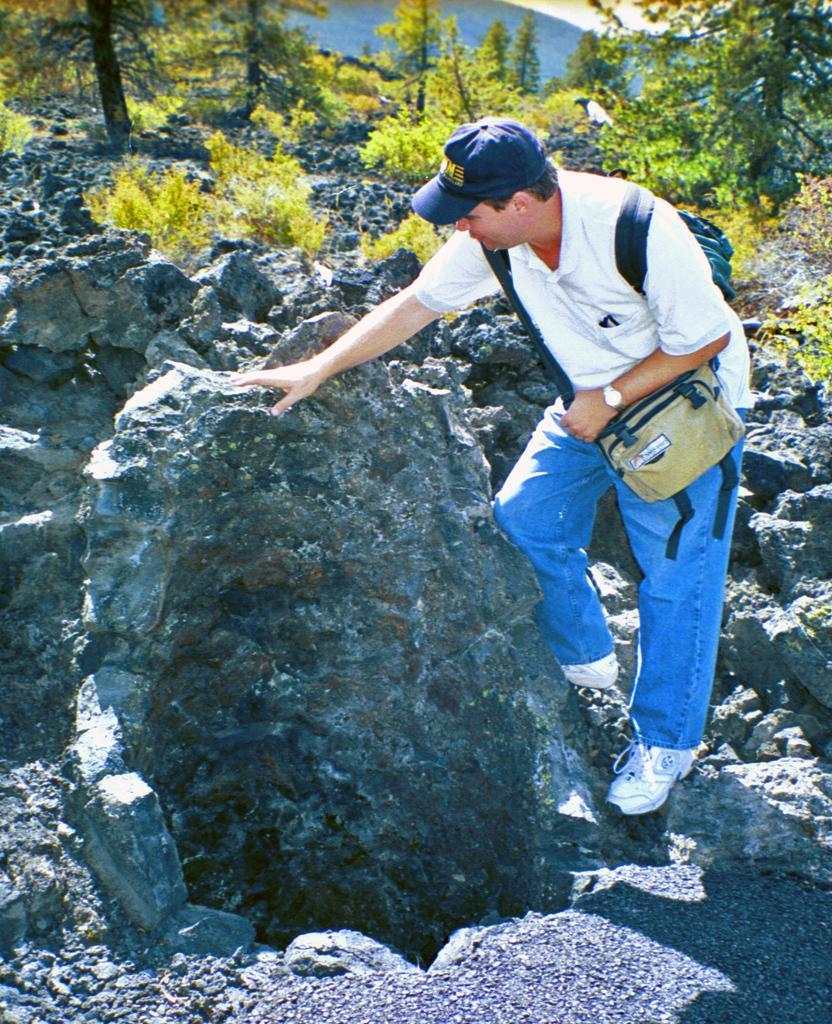Describe this image in one or two sentences. On the right side of the image we can see a man is standing and wearing dress, cap, bags, shoes. In the background of the image we can see the rocks, trees. At the top of the image we can see the hills and sky. 